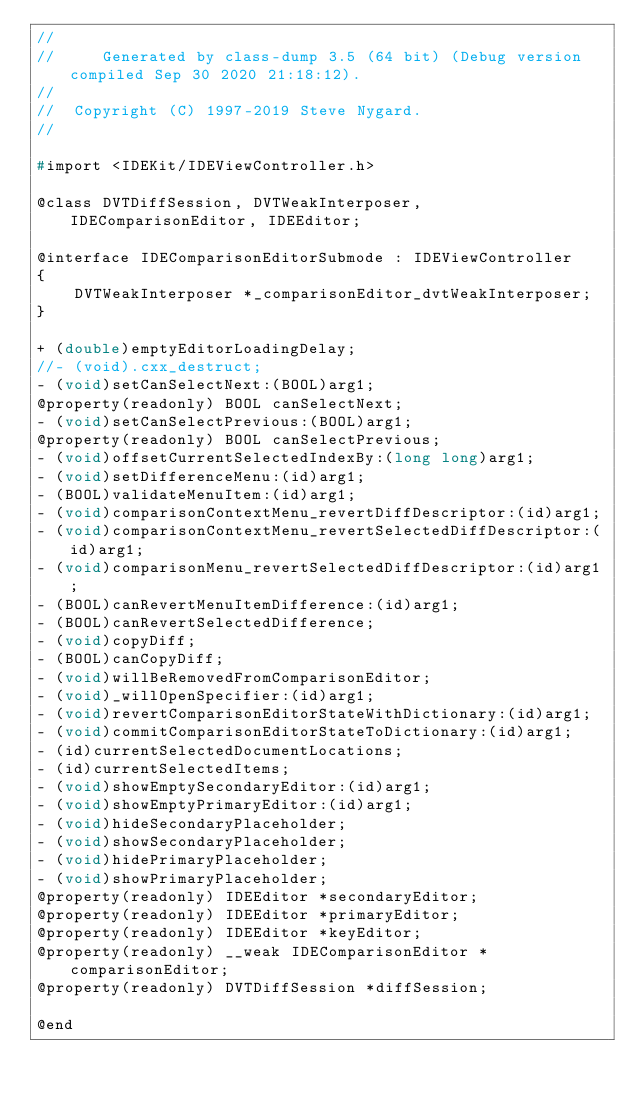<code> <loc_0><loc_0><loc_500><loc_500><_C_>//
//     Generated by class-dump 3.5 (64 bit) (Debug version compiled Sep 30 2020 21:18:12).
//
//  Copyright (C) 1997-2019 Steve Nygard.
//

#import <IDEKit/IDEViewController.h>

@class DVTDiffSession, DVTWeakInterposer, IDEComparisonEditor, IDEEditor;

@interface IDEComparisonEditorSubmode : IDEViewController
{
    DVTWeakInterposer *_comparisonEditor_dvtWeakInterposer;
}

+ (double)emptyEditorLoadingDelay;
//- (void).cxx_destruct;
- (void)setCanSelectNext:(BOOL)arg1;
@property(readonly) BOOL canSelectNext;
- (void)setCanSelectPrevious:(BOOL)arg1;
@property(readonly) BOOL canSelectPrevious;
- (void)offsetCurrentSelectedIndexBy:(long long)arg1;
- (void)setDifferenceMenu:(id)arg1;
- (BOOL)validateMenuItem:(id)arg1;
- (void)comparisonContextMenu_revertDiffDescriptor:(id)arg1;
- (void)comparisonContextMenu_revertSelectedDiffDescriptor:(id)arg1;
- (void)comparisonMenu_revertSelectedDiffDescriptor:(id)arg1;
- (BOOL)canRevertMenuItemDifference:(id)arg1;
- (BOOL)canRevertSelectedDifference;
- (void)copyDiff;
- (BOOL)canCopyDiff;
- (void)willBeRemovedFromComparisonEditor;
- (void)_willOpenSpecifier:(id)arg1;
- (void)revertComparisonEditorStateWithDictionary:(id)arg1;
- (void)commitComparisonEditorStateToDictionary:(id)arg1;
- (id)currentSelectedDocumentLocations;
- (id)currentSelectedItems;
- (void)showEmptySecondaryEditor:(id)arg1;
- (void)showEmptyPrimaryEditor:(id)arg1;
- (void)hideSecondaryPlaceholder;
- (void)showSecondaryPlaceholder;
- (void)hidePrimaryPlaceholder;
- (void)showPrimaryPlaceholder;
@property(readonly) IDEEditor *secondaryEditor;
@property(readonly) IDEEditor *primaryEditor;
@property(readonly) IDEEditor *keyEditor;
@property(readonly) __weak IDEComparisonEditor *comparisonEditor;
@property(readonly) DVTDiffSession *diffSession;

@end

</code> 